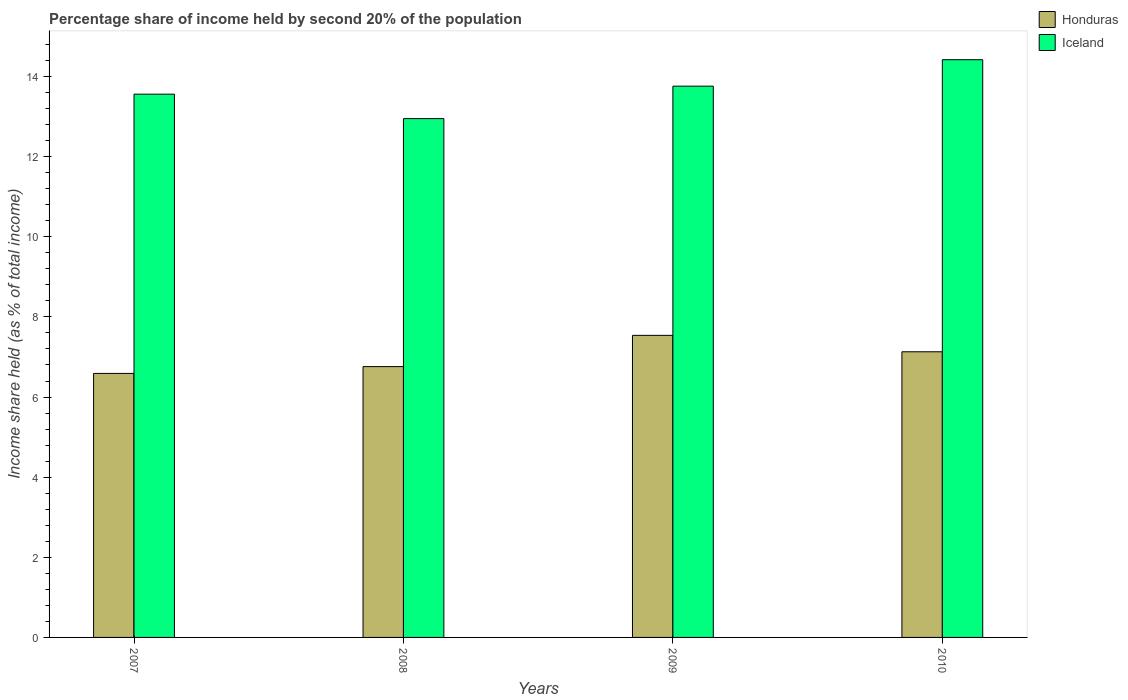How many different coloured bars are there?
Provide a succinct answer. 2. How many groups of bars are there?
Provide a succinct answer. 4. How many bars are there on the 2nd tick from the right?
Your answer should be compact. 2. What is the label of the 3rd group of bars from the left?
Provide a short and direct response. 2009. What is the share of income held by second 20% of the population in Iceland in 2010?
Provide a succinct answer. 14.42. Across all years, what is the maximum share of income held by second 20% of the population in Honduras?
Keep it short and to the point. 7.54. Across all years, what is the minimum share of income held by second 20% of the population in Iceland?
Provide a succinct answer. 12.95. What is the total share of income held by second 20% of the population in Honduras in the graph?
Provide a succinct answer. 28.02. What is the difference between the share of income held by second 20% of the population in Iceland in 2007 and that in 2009?
Provide a short and direct response. -0.2. What is the difference between the share of income held by second 20% of the population in Iceland in 2010 and the share of income held by second 20% of the population in Honduras in 2009?
Ensure brevity in your answer.  6.88. What is the average share of income held by second 20% of the population in Iceland per year?
Provide a succinct answer. 13.67. In the year 2007, what is the difference between the share of income held by second 20% of the population in Honduras and share of income held by second 20% of the population in Iceland?
Offer a terse response. -6.97. What is the ratio of the share of income held by second 20% of the population in Honduras in 2007 to that in 2009?
Your answer should be compact. 0.87. Is the difference between the share of income held by second 20% of the population in Honduras in 2009 and 2010 greater than the difference between the share of income held by second 20% of the population in Iceland in 2009 and 2010?
Provide a succinct answer. Yes. What is the difference between the highest and the second highest share of income held by second 20% of the population in Iceland?
Offer a very short reply. 0.66. What is the difference between the highest and the lowest share of income held by second 20% of the population in Iceland?
Provide a short and direct response. 1.47. What does the 1st bar from the left in 2010 represents?
Your response must be concise. Honduras. What does the 1st bar from the right in 2010 represents?
Keep it short and to the point. Iceland. How many bars are there?
Your answer should be very brief. 8. Are the values on the major ticks of Y-axis written in scientific E-notation?
Your answer should be very brief. No. Does the graph contain any zero values?
Provide a short and direct response. No. Where does the legend appear in the graph?
Keep it short and to the point. Top right. What is the title of the graph?
Your answer should be very brief. Percentage share of income held by second 20% of the population. Does "Uruguay" appear as one of the legend labels in the graph?
Provide a succinct answer. No. What is the label or title of the Y-axis?
Ensure brevity in your answer.  Income share held (as % of total income). What is the Income share held (as % of total income) in Honduras in 2007?
Your answer should be compact. 6.59. What is the Income share held (as % of total income) in Iceland in 2007?
Keep it short and to the point. 13.56. What is the Income share held (as % of total income) of Honduras in 2008?
Ensure brevity in your answer.  6.76. What is the Income share held (as % of total income) in Iceland in 2008?
Provide a succinct answer. 12.95. What is the Income share held (as % of total income) of Honduras in 2009?
Provide a short and direct response. 7.54. What is the Income share held (as % of total income) in Iceland in 2009?
Offer a very short reply. 13.76. What is the Income share held (as % of total income) of Honduras in 2010?
Make the answer very short. 7.13. What is the Income share held (as % of total income) of Iceland in 2010?
Offer a very short reply. 14.42. Across all years, what is the maximum Income share held (as % of total income) in Honduras?
Make the answer very short. 7.54. Across all years, what is the maximum Income share held (as % of total income) in Iceland?
Your answer should be very brief. 14.42. Across all years, what is the minimum Income share held (as % of total income) of Honduras?
Offer a very short reply. 6.59. Across all years, what is the minimum Income share held (as % of total income) in Iceland?
Provide a succinct answer. 12.95. What is the total Income share held (as % of total income) of Honduras in the graph?
Your response must be concise. 28.02. What is the total Income share held (as % of total income) in Iceland in the graph?
Keep it short and to the point. 54.69. What is the difference between the Income share held (as % of total income) in Honduras in 2007 and that in 2008?
Give a very brief answer. -0.17. What is the difference between the Income share held (as % of total income) of Iceland in 2007 and that in 2008?
Give a very brief answer. 0.61. What is the difference between the Income share held (as % of total income) of Honduras in 2007 and that in 2009?
Provide a succinct answer. -0.95. What is the difference between the Income share held (as % of total income) in Iceland in 2007 and that in 2009?
Your answer should be very brief. -0.2. What is the difference between the Income share held (as % of total income) in Honduras in 2007 and that in 2010?
Make the answer very short. -0.54. What is the difference between the Income share held (as % of total income) in Iceland in 2007 and that in 2010?
Make the answer very short. -0.86. What is the difference between the Income share held (as % of total income) in Honduras in 2008 and that in 2009?
Your response must be concise. -0.78. What is the difference between the Income share held (as % of total income) in Iceland in 2008 and that in 2009?
Keep it short and to the point. -0.81. What is the difference between the Income share held (as % of total income) of Honduras in 2008 and that in 2010?
Your answer should be very brief. -0.37. What is the difference between the Income share held (as % of total income) in Iceland in 2008 and that in 2010?
Your answer should be compact. -1.47. What is the difference between the Income share held (as % of total income) in Honduras in 2009 and that in 2010?
Your response must be concise. 0.41. What is the difference between the Income share held (as % of total income) in Iceland in 2009 and that in 2010?
Provide a succinct answer. -0.66. What is the difference between the Income share held (as % of total income) of Honduras in 2007 and the Income share held (as % of total income) of Iceland in 2008?
Ensure brevity in your answer.  -6.36. What is the difference between the Income share held (as % of total income) in Honduras in 2007 and the Income share held (as % of total income) in Iceland in 2009?
Offer a very short reply. -7.17. What is the difference between the Income share held (as % of total income) of Honduras in 2007 and the Income share held (as % of total income) of Iceland in 2010?
Your answer should be compact. -7.83. What is the difference between the Income share held (as % of total income) in Honduras in 2008 and the Income share held (as % of total income) in Iceland in 2010?
Make the answer very short. -7.66. What is the difference between the Income share held (as % of total income) of Honduras in 2009 and the Income share held (as % of total income) of Iceland in 2010?
Your answer should be compact. -6.88. What is the average Income share held (as % of total income) of Honduras per year?
Your answer should be very brief. 7. What is the average Income share held (as % of total income) of Iceland per year?
Your answer should be compact. 13.67. In the year 2007, what is the difference between the Income share held (as % of total income) in Honduras and Income share held (as % of total income) in Iceland?
Provide a short and direct response. -6.97. In the year 2008, what is the difference between the Income share held (as % of total income) in Honduras and Income share held (as % of total income) in Iceland?
Make the answer very short. -6.19. In the year 2009, what is the difference between the Income share held (as % of total income) in Honduras and Income share held (as % of total income) in Iceland?
Give a very brief answer. -6.22. In the year 2010, what is the difference between the Income share held (as % of total income) in Honduras and Income share held (as % of total income) in Iceland?
Offer a very short reply. -7.29. What is the ratio of the Income share held (as % of total income) in Honduras in 2007 to that in 2008?
Your response must be concise. 0.97. What is the ratio of the Income share held (as % of total income) in Iceland in 2007 to that in 2008?
Ensure brevity in your answer.  1.05. What is the ratio of the Income share held (as % of total income) of Honduras in 2007 to that in 2009?
Make the answer very short. 0.87. What is the ratio of the Income share held (as % of total income) of Iceland in 2007 to that in 2009?
Keep it short and to the point. 0.99. What is the ratio of the Income share held (as % of total income) of Honduras in 2007 to that in 2010?
Ensure brevity in your answer.  0.92. What is the ratio of the Income share held (as % of total income) in Iceland in 2007 to that in 2010?
Your answer should be compact. 0.94. What is the ratio of the Income share held (as % of total income) in Honduras in 2008 to that in 2009?
Your answer should be compact. 0.9. What is the ratio of the Income share held (as % of total income) of Iceland in 2008 to that in 2009?
Offer a terse response. 0.94. What is the ratio of the Income share held (as % of total income) in Honduras in 2008 to that in 2010?
Make the answer very short. 0.95. What is the ratio of the Income share held (as % of total income) in Iceland in 2008 to that in 2010?
Provide a succinct answer. 0.9. What is the ratio of the Income share held (as % of total income) of Honduras in 2009 to that in 2010?
Offer a terse response. 1.06. What is the ratio of the Income share held (as % of total income) in Iceland in 2009 to that in 2010?
Give a very brief answer. 0.95. What is the difference between the highest and the second highest Income share held (as % of total income) in Honduras?
Make the answer very short. 0.41. What is the difference between the highest and the second highest Income share held (as % of total income) of Iceland?
Ensure brevity in your answer.  0.66. What is the difference between the highest and the lowest Income share held (as % of total income) of Honduras?
Your answer should be very brief. 0.95. What is the difference between the highest and the lowest Income share held (as % of total income) of Iceland?
Your answer should be very brief. 1.47. 